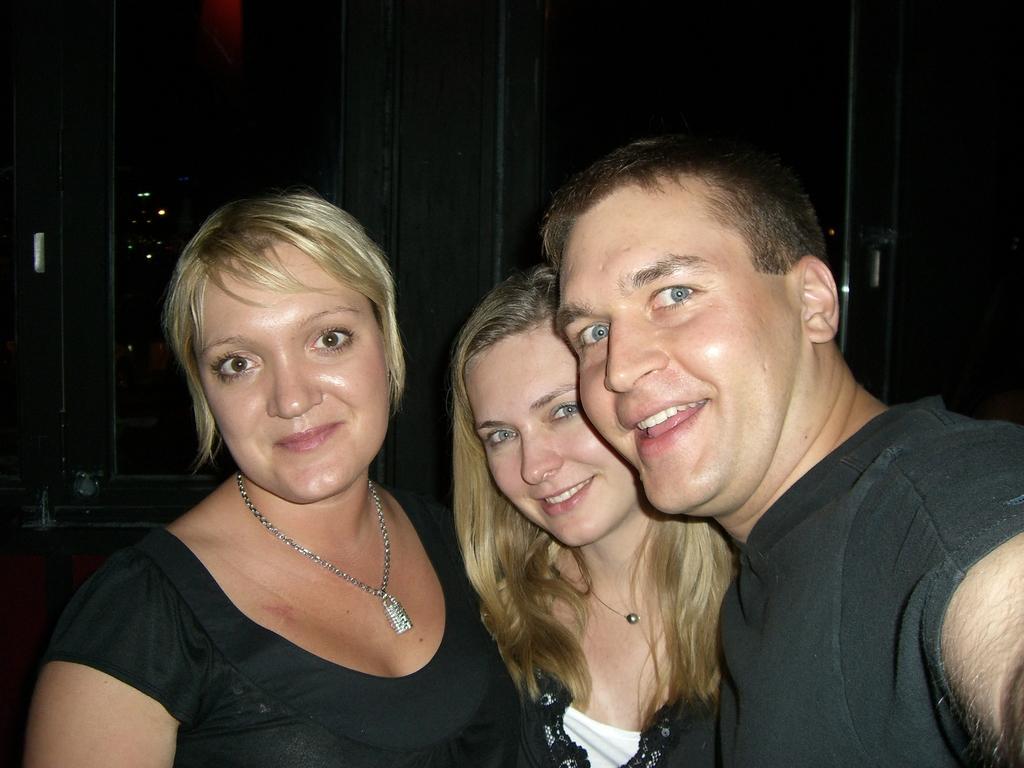Could you give a brief overview of what you see in this image? In this image we can see three people standing and smiling. In the background there is a wall. 